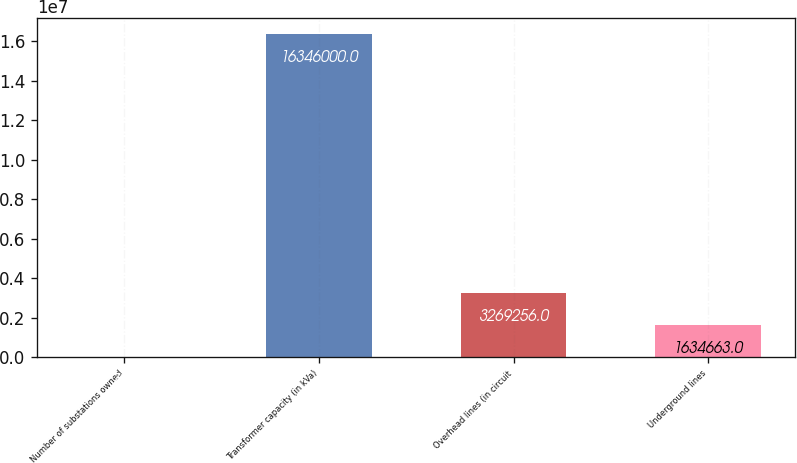Convert chart to OTSL. <chart><loc_0><loc_0><loc_500><loc_500><bar_chart><fcel>Number of substations owned<fcel>Transformer capacity (in kVa)<fcel>Overhead lines (in circuit<fcel>Underground lines<nl><fcel>70<fcel>1.6346e+07<fcel>3.26926e+06<fcel>1.63466e+06<nl></chart> 